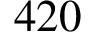Convert formula to latex. <formula><loc_0><loc_0><loc_500><loc_500>4 2 0</formula> 